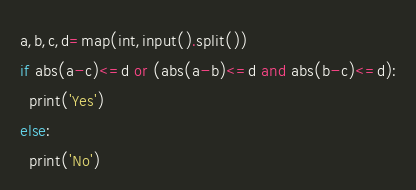Convert code to text. <code><loc_0><loc_0><loc_500><loc_500><_Python_>a,b,c,d=map(int,input().split())
if abs(a-c)<=d or (abs(a-b)<=d and abs(b-c)<=d):
  print('Yes')
else:
  print('No')</code> 